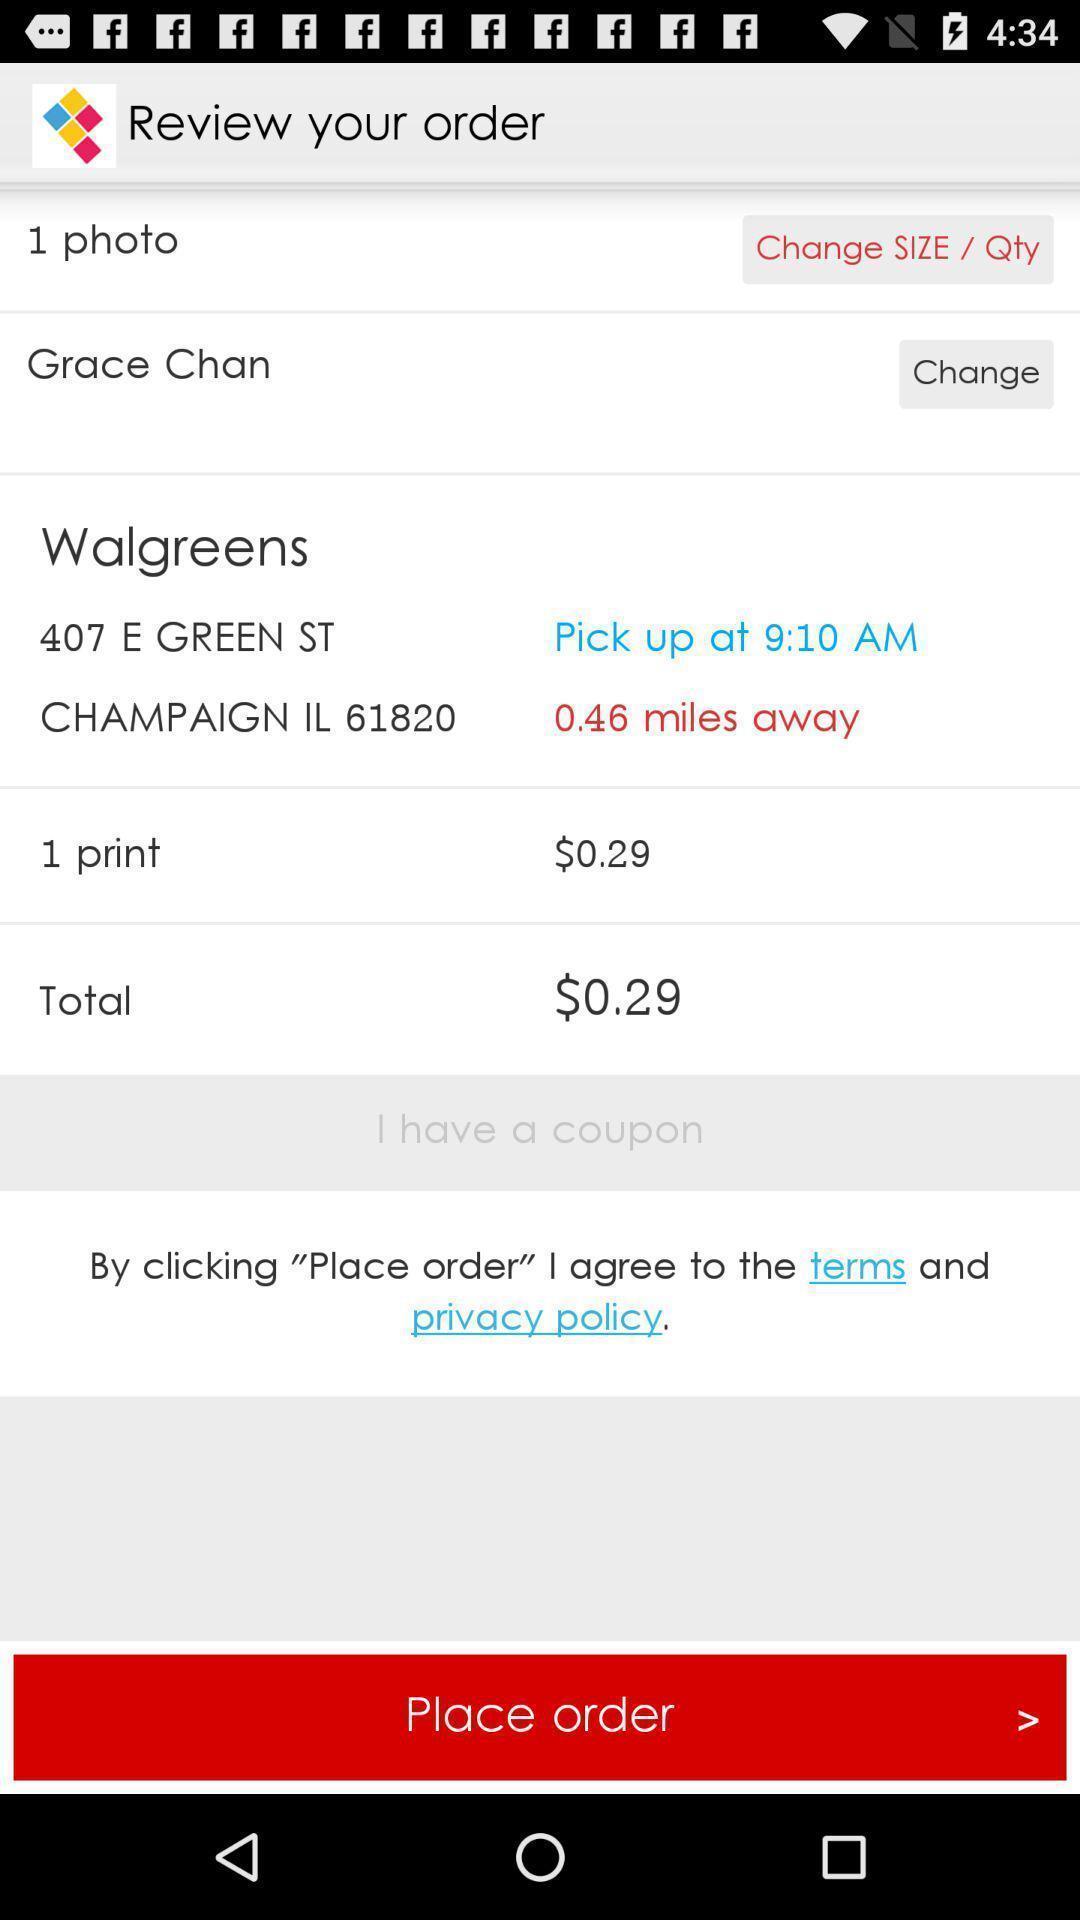Give me a summary of this screen capture. Page for ordering a photo printing. 